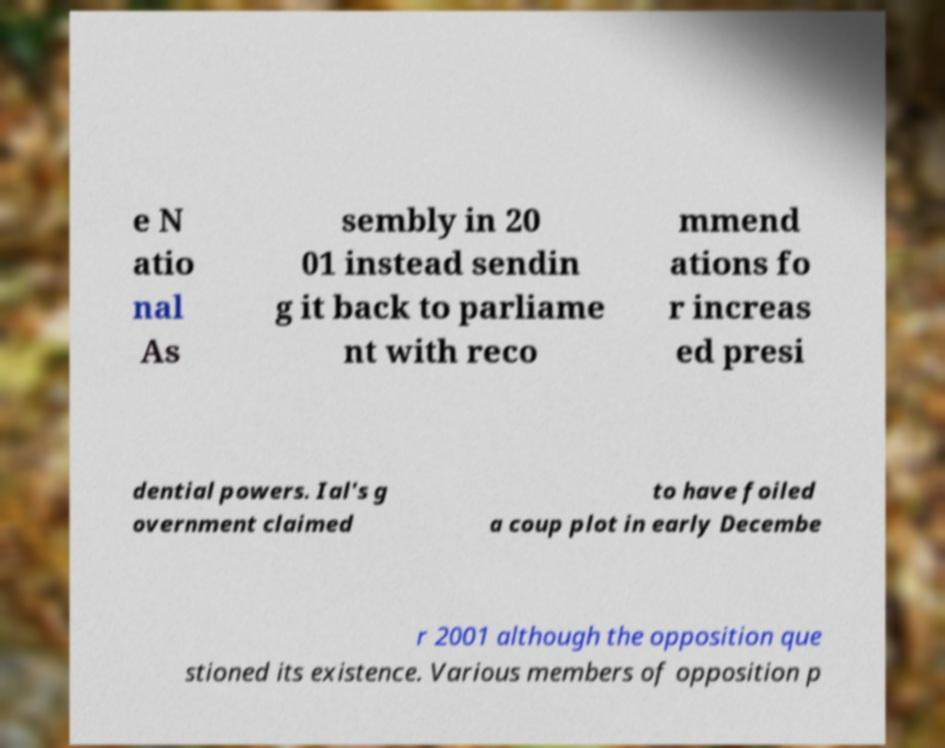What messages or text are displayed in this image? I need them in a readable, typed format. e N atio nal As sembly in 20 01 instead sendin g it back to parliame nt with reco mmend ations fo r increas ed presi dential powers. Ial's g overnment claimed to have foiled a coup plot in early Decembe r 2001 although the opposition que stioned its existence. Various members of opposition p 